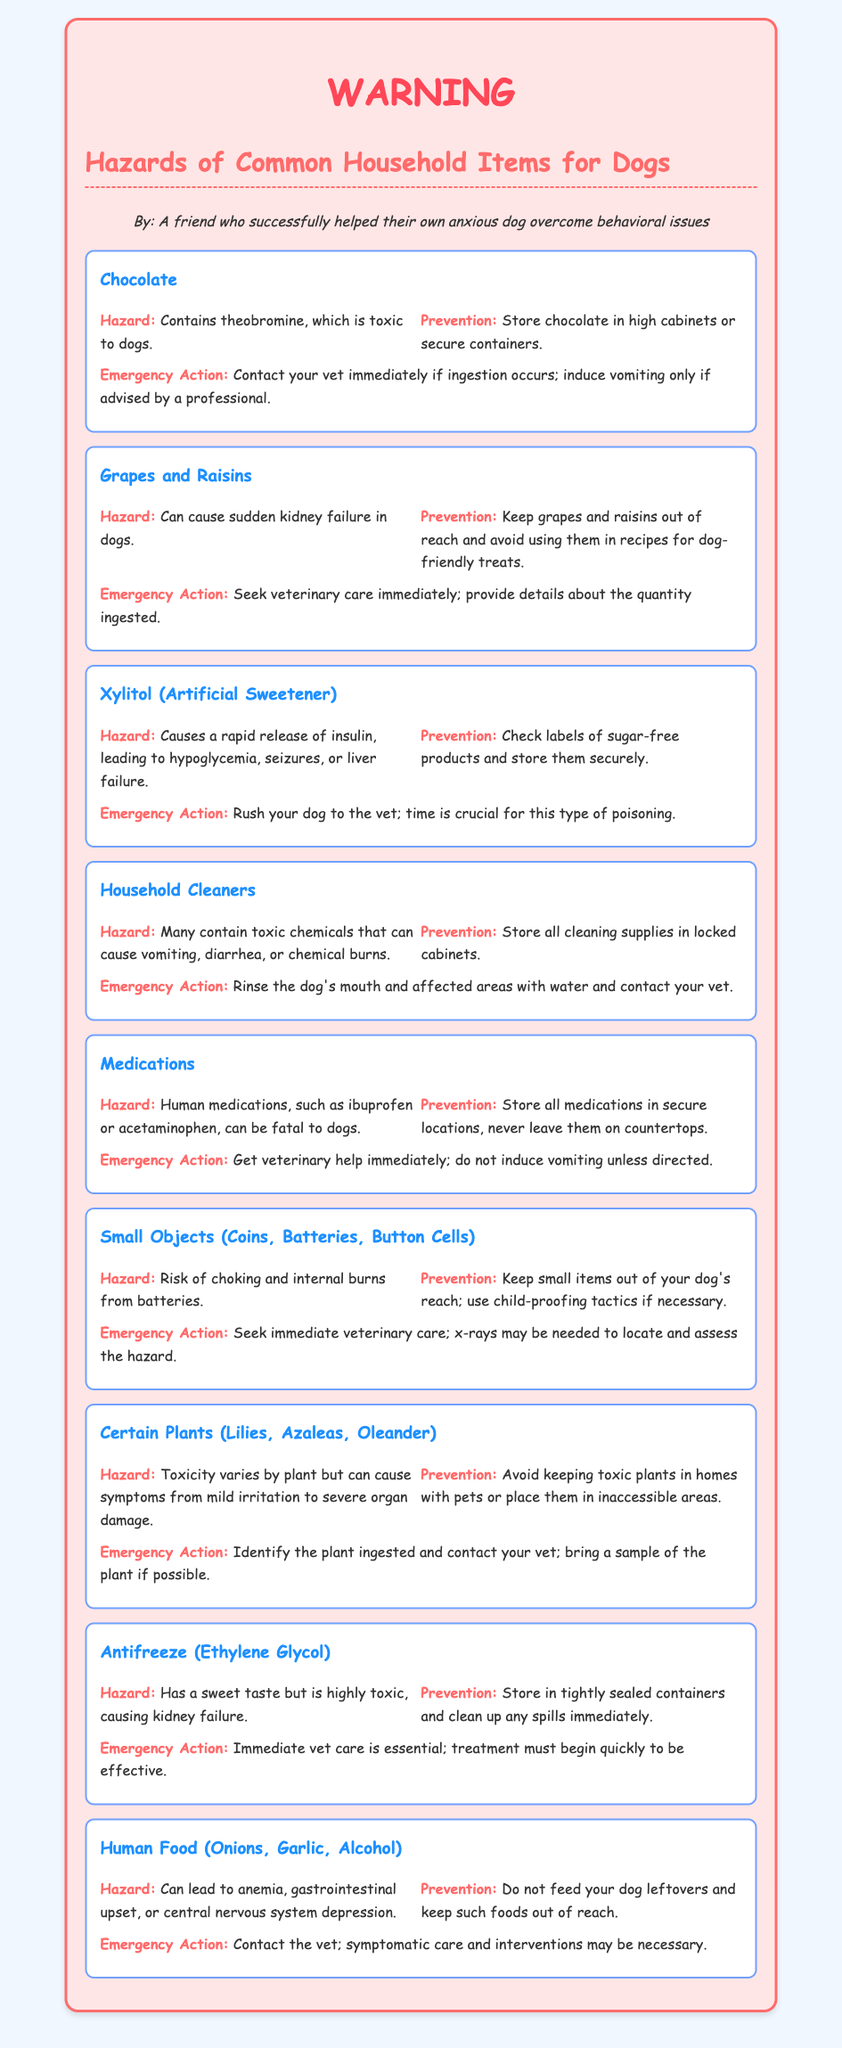What is the first item listed? The first item listed is "Chocolate," which is mentioned as a common household hazard for dogs.
Answer: Chocolate What hazard does Xylitol cause? Xylitol causes a rapid release of insulin, leading to hypoglycemia, seizures, or liver failure.
Answer: Hypoglycemia, seizures, or liver failure What should you do if your dog ingests a household cleaner? You should rinse the dog's mouth and affected areas with water and contact your vet for further advice.
Answer: Rinse and contact your vet How many small objects are specifically mentioned as hazards? Three small objects are mentioned: coins, batteries, and button cells.
Answer: Three What is the emergency action for ingested grapes? The emergency action is to seek veterinary care immediately.
Answer: Seek veterinary care Which household item requires immediate vet care due to kidney failure? Antifreeze (Ethylene Glycol) causes kidney failure and requires immediate veterinary care.
Answer: Antifreeze (Ethylene Glycol) What is a prevention tip for household medications? Store all medications in secure locations and never leave them on countertops.
Answer: Secure storage What type of symptoms can human food like onions cause in dogs? Human food can lead to anemia, gastrointestinal upset, or central nervous system depression in dogs.
Answer: Anemia, gastrointestinal upset, or CNS depression 